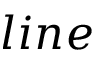Convert formula to latex. <formula><loc_0><loc_0><loc_500><loc_500>l i n e</formula> 